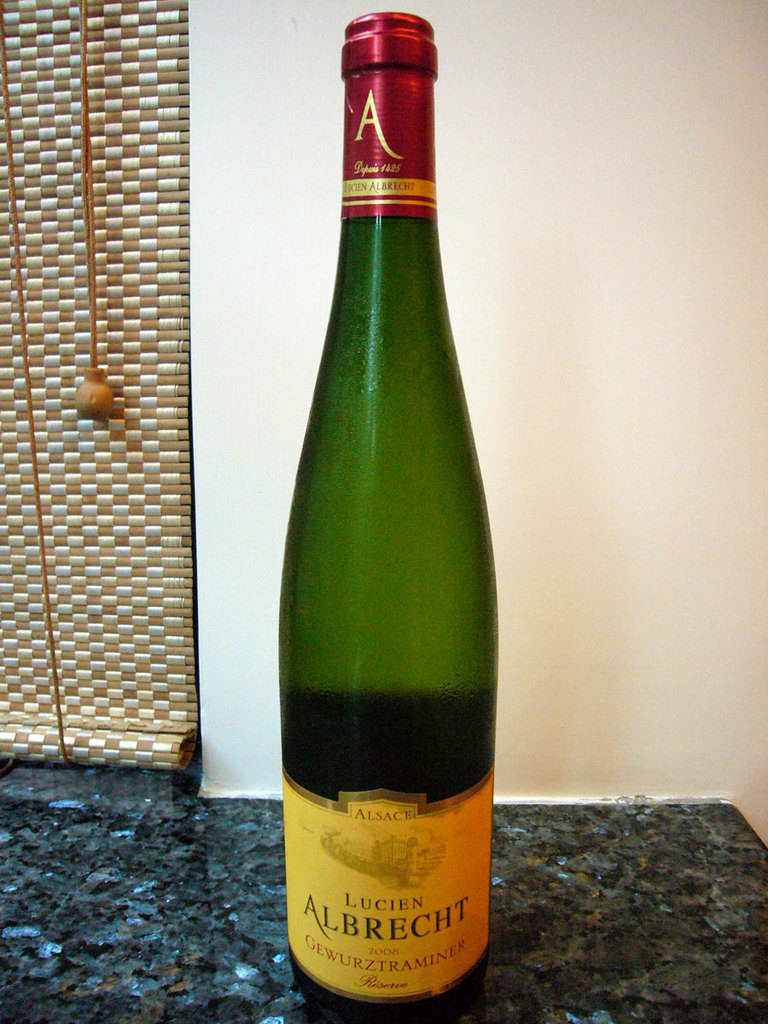Provide a one-sentence caption for the provided image. A 2008 Lucien Albrecht Gewurztraminer wine bottle sits elegantly on a granite countertop, its vibrant label reflecting its rich Alsatian heritage and promising a floral and spicy bouquet. 